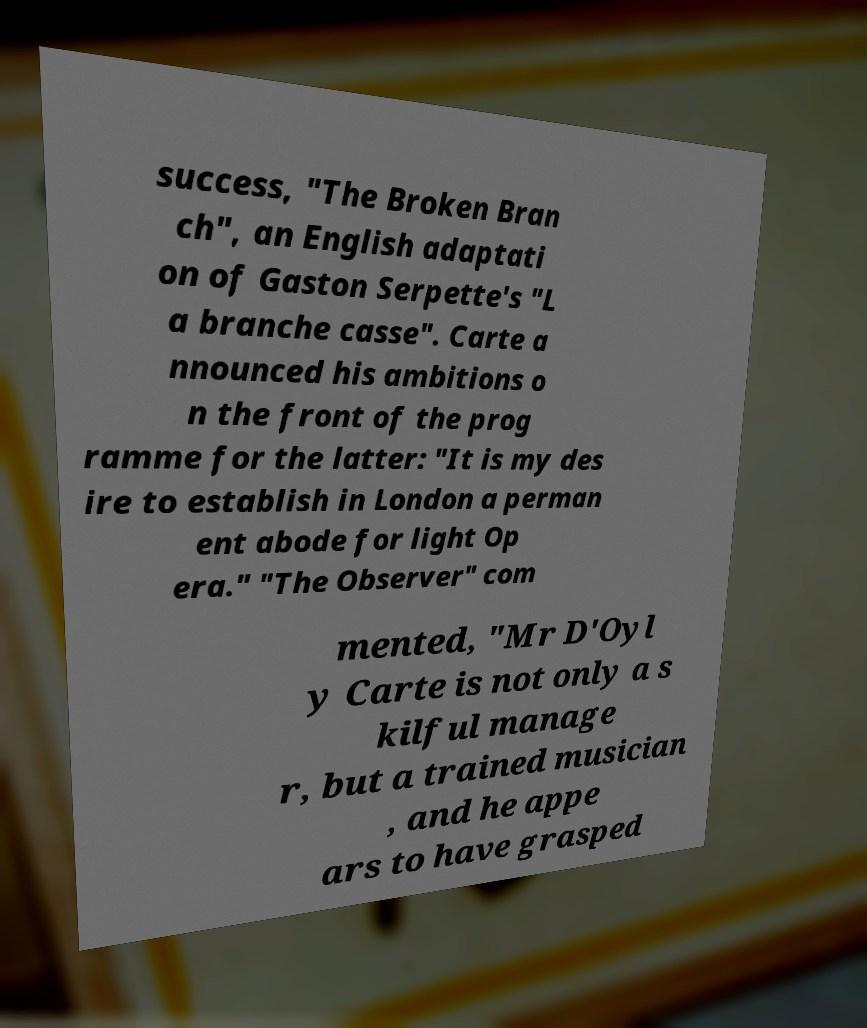Please read and relay the text visible in this image. What does it say? success, "The Broken Bran ch", an English adaptati on of Gaston Serpette's "L a branche casse". Carte a nnounced his ambitions o n the front of the prog ramme for the latter: "It is my des ire to establish in London a perman ent abode for light Op era." "The Observer" com mented, "Mr D'Oyl y Carte is not only a s kilful manage r, but a trained musician , and he appe ars to have grasped 